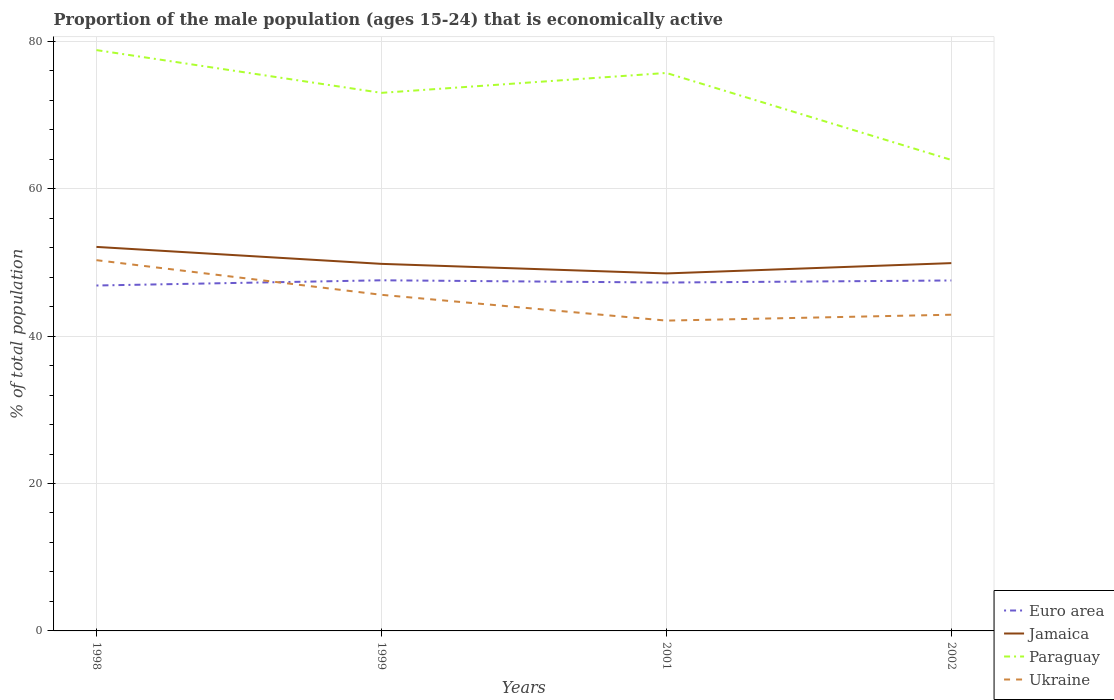Does the line corresponding to Ukraine intersect with the line corresponding to Paraguay?
Ensure brevity in your answer.  No. Across all years, what is the maximum proportion of the male population that is economically active in Euro area?
Provide a short and direct response. 46.86. What is the total proportion of the male population that is economically active in Euro area in the graph?
Offer a terse response. 0.31. What is the difference between the highest and the second highest proportion of the male population that is economically active in Paraguay?
Ensure brevity in your answer.  14.9. How many lines are there?
Your response must be concise. 4. What is the difference between two consecutive major ticks on the Y-axis?
Offer a very short reply. 20. Are the values on the major ticks of Y-axis written in scientific E-notation?
Offer a terse response. No. Does the graph contain any zero values?
Keep it short and to the point. No. Does the graph contain grids?
Make the answer very short. Yes. How many legend labels are there?
Make the answer very short. 4. How are the legend labels stacked?
Provide a succinct answer. Vertical. What is the title of the graph?
Keep it short and to the point. Proportion of the male population (ages 15-24) that is economically active. Does "Trinidad and Tobago" appear as one of the legend labels in the graph?
Make the answer very short. No. What is the label or title of the X-axis?
Make the answer very short. Years. What is the label or title of the Y-axis?
Make the answer very short. % of total population. What is the % of total population in Euro area in 1998?
Offer a terse response. 46.86. What is the % of total population in Jamaica in 1998?
Give a very brief answer. 52.1. What is the % of total population of Paraguay in 1998?
Your answer should be very brief. 78.8. What is the % of total population of Ukraine in 1998?
Keep it short and to the point. 50.3. What is the % of total population of Euro area in 1999?
Your answer should be compact. 47.57. What is the % of total population in Jamaica in 1999?
Provide a short and direct response. 49.8. What is the % of total population of Ukraine in 1999?
Your answer should be very brief. 45.6. What is the % of total population of Euro area in 2001?
Your answer should be compact. 47.26. What is the % of total population of Jamaica in 2001?
Provide a short and direct response. 48.5. What is the % of total population in Paraguay in 2001?
Your response must be concise. 75.7. What is the % of total population in Ukraine in 2001?
Your response must be concise. 42.1. What is the % of total population in Euro area in 2002?
Make the answer very short. 47.55. What is the % of total population in Jamaica in 2002?
Provide a succinct answer. 49.9. What is the % of total population of Paraguay in 2002?
Make the answer very short. 63.9. What is the % of total population of Ukraine in 2002?
Offer a very short reply. 42.9. Across all years, what is the maximum % of total population in Euro area?
Keep it short and to the point. 47.57. Across all years, what is the maximum % of total population of Jamaica?
Your response must be concise. 52.1. Across all years, what is the maximum % of total population of Paraguay?
Your answer should be very brief. 78.8. Across all years, what is the maximum % of total population of Ukraine?
Offer a terse response. 50.3. Across all years, what is the minimum % of total population of Euro area?
Provide a short and direct response. 46.86. Across all years, what is the minimum % of total population in Jamaica?
Provide a succinct answer. 48.5. Across all years, what is the minimum % of total population of Paraguay?
Your response must be concise. 63.9. Across all years, what is the minimum % of total population of Ukraine?
Your answer should be very brief. 42.1. What is the total % of total population of Euro area in the graph?
Your answer should be compact. 189.24. What is the total % of total population in Jamaica in the graph?
Your answer should be compact. 200.3. What is the total % of total population of Paraguay in the graph?
Provide a short and direct response. 291.4. What is the total % of total population of Ukraine in the graph?
Ensure brevity in your answer.  180.9. What is the difference between the % of total population of Euro area in 1998 and that in 1999?
Keep it short and to the point. -0.71. What is the difference between the % of total population in Jamaica in 1998 and that in 1999?
Make the answer very short. 2.3. What is the difference between the % of total population in Euro area in 1998 and that in 2001?
Your response must be concise. -0.4. What is the difference between the % of total population of Jamaica in 1998 and that in 2001?
Make the answer very short. 3.6. What is the difference between the % of total population of Paraguay in 1998 and that in 2001?
Offer a very short reply. 3.1. What is the difference between the % of total population in Ukraine in 1998 and that in 2001?
Keep it short and to the point. 8.2. What is the difference between the % of total population in Euro area in 1998 and that in 2002?
Provide a succinct answer. -0.68. What is the difference between the % of total population of Ukraine in 1998 and that in 2002?
Offer a terse response. 7.4. What is the difference between the % of total population in Euro area in 1999 and that in 2001?
Offer a terse response. 0.31. What is the difference between the % of total population in Jamaica in 1999 and that in 2001?
Ensure brevity in your answer.  1.3. What is the difference between the % of total population of Paraguay in 1999 and that in 2001?
Offer a very short reply. -2.7. What is the difference between the % of total population of Ukraine in 1999 and that in 2001?
Give a very brief answer. 3.5. What is the difference between the % of total population of Euro area in 1999 and that in 2002?
Ensure brevity in your answer.  0.03. What is the difference between the % of total population in Jamaica in 1999 and that in 2002?
Provide a short and direct response. -0.1. What is the difference between the % of total population in Euro area in 2001 and that in 2002?
Offer a terse response. -0.28. What is the difference between the % of total population of Jamaica in 2001 and that in 2002?
Provide a short and direct response. -1.4. What is the difference between the % of total population in Ukraine in 2001 and that in 2002?
Offer a terse response. -0.8. What is the difference between the % of total population in Euro area in 1998 and the % of total population in Jamaica in 1999?
Provide a succinct answer. -2.94. What is the difference between the % of total population of Euro area in 1998 and the % of total population of Paraguay in 1999?
Make the answer very short. -26.14. What is the difference between the % of total population in Euro area in 1998 and the % of total population in Ukraine in 1999?
Your answer should be very brief. 1.26. What is the difference between the % of total population of Jamaica in 1998 and the % of total population of Paraguay in 1999?
Make the answer very short. -20.9. What is the difference between the % of total population in Jamaica in 1998 and the % of total population in Ukraine in 1999?
Make the answer very short. 6.5. What is the difference between the % of total population of Paraguay in 1998 and the % of total population of Ukraine in 1999?
Give a very brief answer. 33.2. What is the difference between the % of total population in Euro area in 1998 and the % of total population in Jamaica in 2001?
Provide a succinct answer. -1.64. What is the difference between the % of total population of Euro area in 1998 and the % of total population of Paraguay in 2001?
Your answer should be very brief. -28.84. What is the difference between the % of total population of Euro area in 1998 and the % of total population of Ukraine in 2001?
Keep it short and to the point. 4.76. What is the difference between the % of total population of Jamaica in 1998 and the % of total population of Paraguay in 2001?
Provide a succinct answer. -23.6. What is the difference between the % of total population in Paraguay in 1998 and the % of total population in Ukraine in 2001?
Your answer should be very brief. 36.7. What is the difference between the % of total population in Euro area in 1998 and the % of total population in Jamaica in 2002?
Give a very brief answer. -3.04. What is the difference between the % of total population in Euro area in 1998 and the % of total population in Paraguay in 2002?
Your answer should be compact. -17.04. What is the difference between the % of total population in Euro area in 1998 and the % of total population in Ukraine in 2002?
Make the answer very short. 3.96. What is the difference between the % of total population in Jamaica in 1998 and the % of total population in Paraguay in 2002?
Give a very brief answer. -11.8. What is the difference between the % of total population in Jamaica in 1998 and the % of total population in Ukraine in 2002?
Keep it short and to the point. 9.2. What is the difference between the % of total population in Paraguay in 1998 and the % of total population in Ukraine in 2002?
Offer a terse response. 35.9. What is the difference between the % of total population of Euro area in 1999 and the % of total population of Jamaica in 2001?
Offer a very short reply. -0.93. What is the difference between the % of total population of Euro area in 1999 and the % of total population of Paraguay in 2001?
Provide a short and direct response. -28.13. What is the difference between the % of total population in Euro area in 1999 and the % of total population in Ukraine in 2001?
Keep it short and to the point. 5.47. What is the difference between the % of total population in Jamaica in 1999 and the % of total population in Paraguay in 2001?
Your answer should be compact. -25.9. What is the difference between the % of total population of Jamaica in 1999 and the % of total population of Ukraine in 2001?
Offer a very short reply. 7.7. What is the difference between the % of total population of Paraguay in 1999 and the % of total population of Ukraine in 2001?
Your response must be concise. 30.9. What is the difference between the % of total population of Euro area in 1999 and the % of total population of Jamaica in 2002?
Your answer should be very brief. -2.33. What is the difference between the % of total population in Euro area in 1999 and the % of total population in Paraguay in 2002?
Offer a very short reply. -16.33. What is the difference between the % of total population in Euro area in 1999 and the % of total population in Ukraine in 2002?
Give a very brief answer. 4.67. What is the difference between the % of total population of Jamaica in 1999 and the % of total population of Paraguay in 2002?
Keep it short and to the point. -14.1. What is the difference between the % of total population in Jamaica in 1999 and the % of total population in Ukraine in 2002?
Your answer should be compact. 6.9. What is the difference between the % of total population of Paraguay in 1999 and the % of total population of Ukraine in 2002?
Give a very brief answer. 30.1. What is the difference between the % of total population in Euro area in 2001 and the % of total population in Jamaica in 2002?
Keep it short and to the point. -2.64. What is the difference between the % of total population of Euro area in 2001 and the % of total population of Paraguay in 2002?
Make the answer very short. -16.64. What is the difference between the % of total population of Euro area in 2001 and the % of total population of Ukraine in 2002?
Offer a terse response. 4.36. What is the difference between the % of total population in Jamaica in 2001 and the % of total population in Paraguay in 2002?
Make the answer very short. -15.4. What is the difference between the % of total population of Jamaica in 2001 and the % of total population of Ukraine in 2002?
Give a very brief answer. 5.6. What is the difference between the % of total population in Paraguay in 2001 and the % of total population in Ukraine in 2002?
Provide a succinct answer. 32.8. What is the average % of total population of Euro area per year?
Provide a succinct answer. 47.31. What is the average % of total population in Jamaica per year?
Your answer should be very brief. 50.08. What is the average % of total population in Paraguay per year?
Keep it short and to the point. 72.85. What is the average % of total population of Ukraine per year?
Offer a terse response. 45.23. In the year 1998, what is the difference between the % of total population in Euro area and % of total population in Jamaica?
Make the answer very short. -5.24. In the year 1998, what is the difference between the % of total population in Euro area and % of total population in Paraguay?
Your answer should be very brief. -31.94. In the year 1998, what is the difference between the % of total population of Euro area and % of total population of Ukraine?
Your answer should be very brief. -3.44. In the year 1998, what is the difference between the % of total population in Jamaica and % of total population in Paraguay?
Your answer should be compact. -26.7. In the year 1999, what is the difference between the % of total population in Euro area and % of total population in Jamaica?
Keep it short and to the point. -2.23. In the year 1999, what is the difference between the % of total population of Euro area and % of total population of Paraguay?
Ensure brevity in your answer.  -25.43. In the year 1999, what is the difference between the % of total population in Euro area and % of total population in Ukraine?
Provide a succinct answer. 1.97. In the year 1999, what is the difference between the % of total population of Jamaica and % of total population of Paraguay?
Offer a terse response. -23.2. In the year 1999, what is the difference between the % of total population in Jamaica and % of total population in Ukraine?
Offer a terse response. 4.2. In the year 1999, what is the difference between the % of total population of Paraguay and % of total population of Ukraine?
Make the answer very short. 27.4. In the year 2001, what is the difference between the % of total population of Euro area and % of total population of Jamaica?
Your answer should be very brief. -1.24. In the year 2001, what is the difference between the % of total population in Euro area and % of total population in Paraguay?
Offer a terse response. -28.44. In the year 2001, what is the difference between the % of total population in Euro area and % of total population in Ukraine?
Provide a succinct answer. 5.16. In the year 2001, what is the difference between the % of total population of Jamaica and % of total population of Paraguay?
Give a very brief answer. -27.2. In the year 2001, what is the difference between the % of total population in Paraguay and % of total population in Ukraine?
Provide a succinct answer. 33.6. In the year 2002, what is the difference between the % of total population of Euro area and % of total population of Jamaica?
Make the answer very short. -2.35. In the year 2002, what is the difference between the % of total population in Euro area and % of total population in Paraguay?
Make the answer very short. -16.35. In the year 2002, what is the difference between the % of total population in Euro area and % of total population in Ukraine?
Offer a very short reply. 4.65. In the year 2002, what is the difference between the % of total population of Jamaica and % of total population of Paraguay?
Offer a terse response. -14. In the year 2002, what is the difference between the % of total population of Jamaica and % of total population of Ukraine?
Offer a terse response. 7. In the year 2002, what is the difference between the % of total population in Paraguay and % of total population in Ukraine?
Make the answer very short. 21. What is the ratio of the % of total population in Euro area in 1998 to that in 1999?
Provide a short and direct response. 0.99. What is the ratio of the % of total population in Jamaica in 1998 to that in 1999?
Provide a succinct answer. 1.05. What is the ratio of the % of total population of Paraguay in 1998 to that in 1999?
Keep it short and to the point. 1.08. What is the ratio of the % of total population of Ukraine in 1998 to that in 1999?
Offer a very short reply. 1.1. What is the ratio of the % of total population in Jamaica in 1998 to that in 2001?
Provide a succinct answer. 1.07. What is the ratio of the % of total population of Paraguay in 1998 to that in 2001?
Offer a very short reply. 1.04. What is the ratio of the % of total population in Ukraine in 1998 to that in 2001?
Your answer should be very brief. 1.19. What is the ratio of the % of total population in Euro area in 1998 to that in 2002?
Make the answer very short. 0.99. What is the ratio of the % of total population of Jamaica in 1998 to that in 2002?
Keep it short and to the point. 1.04. What is the ratio of the % of total population in Paraguay in 1998 to that in 2002?
Your answer should be very brief. 1.23. What is the ratio of the % of total population of Ukraine in 1998 to that in 2002?
Provide a short and direct response. 1.17. What is the ratio of the % of total population in Euro area in 1999 to that in 2001?
Give a very brief answer. 1.01. What is the ratio of the % of total population of Jamaica in 1999 to that in 2001?
Your response must be concise. 1.03. What is the ratio of the % of total population in Ukraine in 1999 to that in 2001?
Provide a short and direct response. 1.08. What is the ratio of the % of total population of Jamaica in 1999 to that in 2002?
Your answer should be very brief. 1. What is the ratio of the % of total population in Paraguay in 1999 to that in 2002?
Make the answer very short. 1.14. What is the ratio of the % of total population of Ukraine in 1999 to that in 2002?
Your response must be concise. 1.06. What is the ratio of the % of total population of Euro area in 2001 to that in 2002?
Your answer should be very brief. 0.99. What is the ratio of the % of total population of Jamaica in 2001 to that in 2002?
Provide a succinct answer. 0.97. What is the ratio of the % of total population of Paraguay in 2001 to that in 2002?
Your answer should be compact. 1.18. What is the ratio of the % of total population of Ukraine in 2001 to that in 2002?
Offer a very short reply. 0.98. What is the difference between the highest and the second highest % of total population in Euro area?
Make the answer very short. 0.03. What is the difference between the highest and the second highest % of total population of Jamaica?
Make the answer very short. 2.2. What is the difference between the highest and the second highest % of total population of Paraguay?
Offer a very short reply. 3.1. What is the difference between the highest and the lowest % of total population of Euro area?
Make the answer very short. 0.71. What is the difference between the highest and the lowest % of total population of Jamaica?
Offer a terse response. 3.6. 